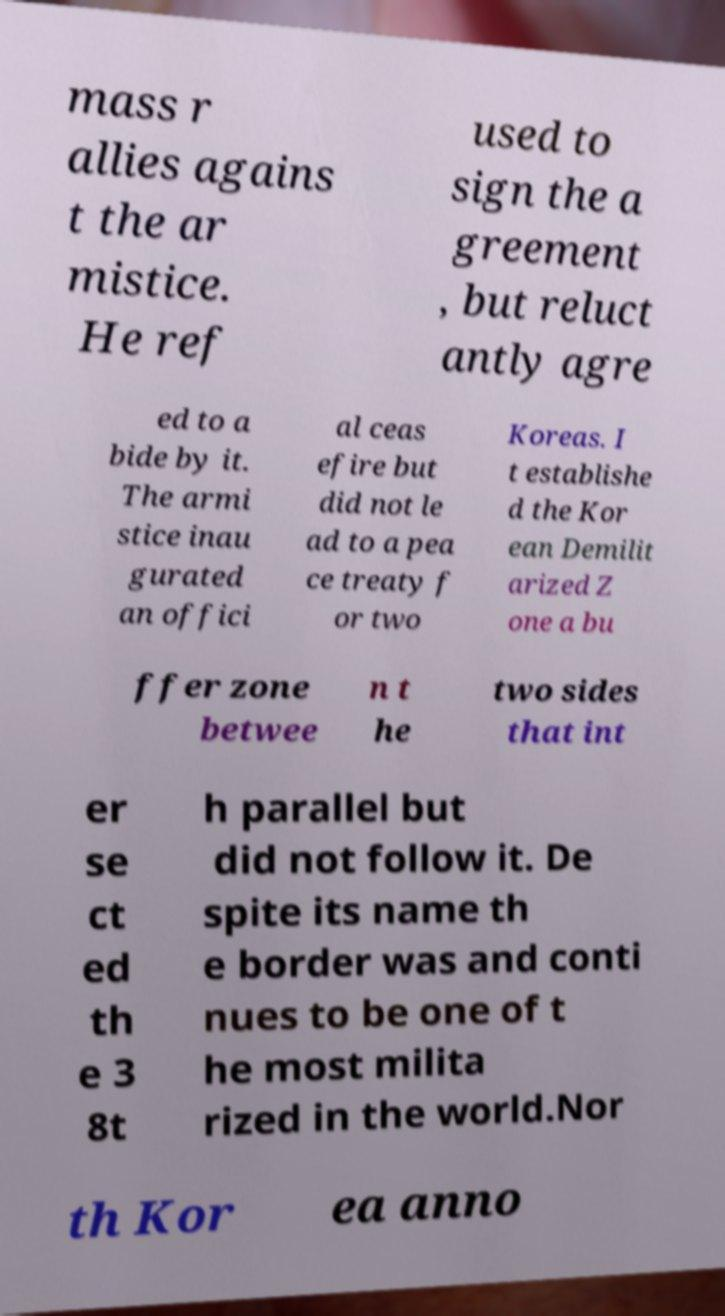I need the written content from this picture converted into text. Can you do that? mass r allies agains t the ar mistice. He ref used to sign the a greement , but reluct antly agre ed to a bide by it. The armi stice inau gurated an offici al ceas efire but did not le ad to a pea ce treaty f or two Koreas. I t establishe d the Kor ean Demilit arized Z one a bu ffer zone betwee n t he two sides that int er se ct ed th e 3 8t h parallel but did not follow it. De spite its name th e border was and conti nues to be one of t he most milita rized in the world.Nor th Kor ea anno 